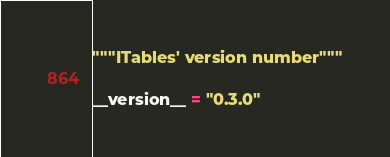Convert code to text. <code><loc_0><loc_0><loc_500><loc_500><_Python_>"""ITables' version number"""

__version__ = "0.3.0"
</code> 